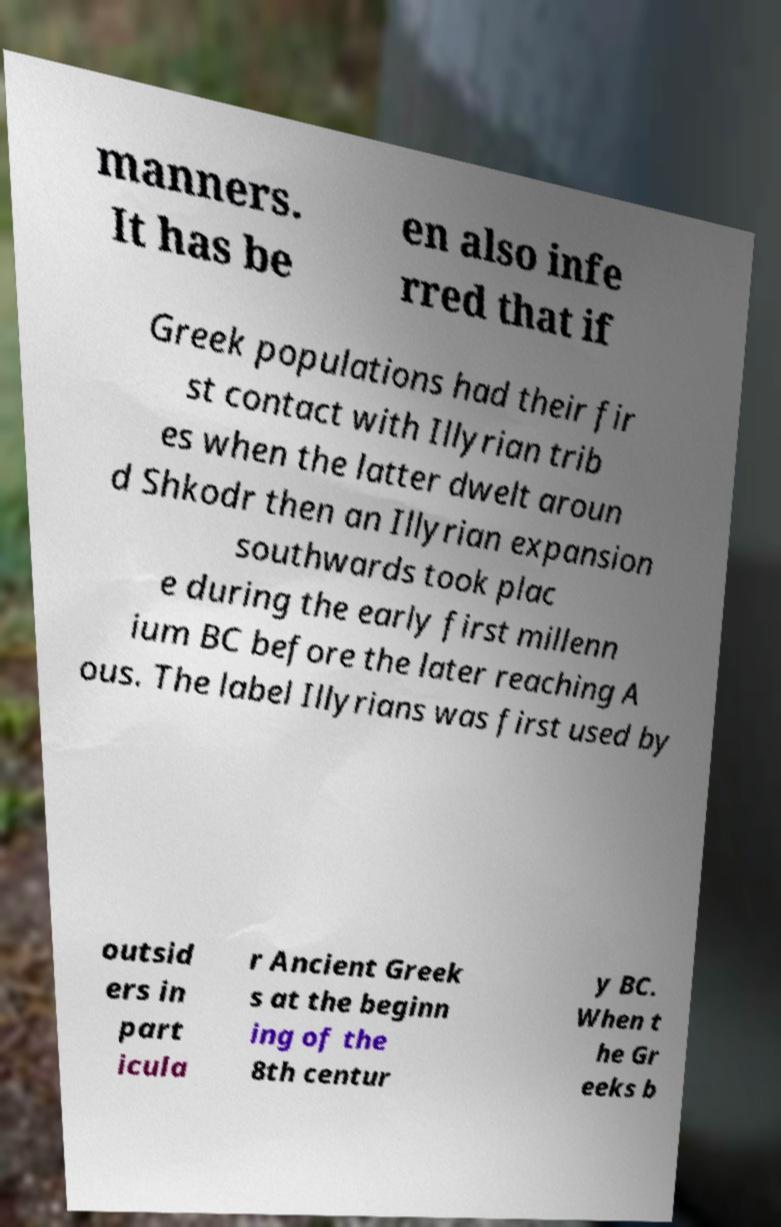Could you extract and type out the text from this image? manners. It has be en also infe rred that if Greek populations had their fir st contact with Illyrian trib es when the latter dwelt aroun d Shkodr then an Illyrian expansion southwards took plac e during the early first millenn ium BC before the later reaching A ous. The label Illyrians was first used by outsid ers in part icula r Ancient Greek s at the beginn ing of the 8th centur y BC. When t he Gr eeks b 